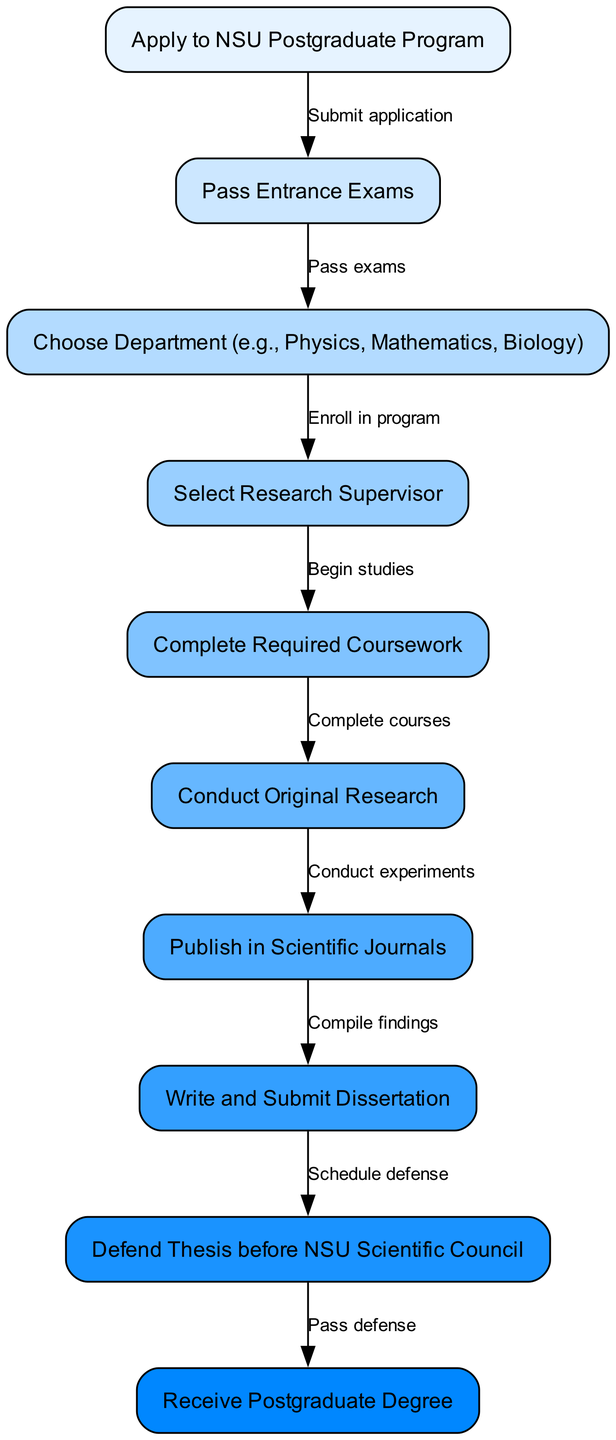What is the first step in obtaining a postgraduate degree at NSU? The diagram shows that the first step is to apply to the NSU Postgraduate Program, indicated by the node labeled "Apply to NSU Postgraduate Program."
Answer: Apply to NSU Postgraduate Program How many nodes are there in the diagram? By counting the nodes listed in the data, there are a total of 10 nodes.
Answer: 10 What is required to advance from "Entrance Exams" to "Choose Department"? The edge connecting these two nodes states that one must pass the exams to proceed, as specified in the text on that edge.
Answer: Pass exams What is the last step before receiving the postgraduate degree? The diagram shows that one must pass the defense first, which is the final step indicated before receiving the degree.
Answer: Pass defense Which step follows "Conduct Original Research"? According to the flow of the diagram, after conducting research, the next step is to publish findings in scientific journals. This is demonstrated by the edge linking these two nodes.
Answer: Publish in Scientific Journals What happens directly after completing required coursework? Upon completing required coursework, the next step is to conduct original research, as illustrated by the connection from "Complete Required Coursework" to "Conduct Original Research."
Answer: Conduct Original Research How many edges are listed in the diagram? By examining the edges provided in the data, there are a total of 9 edges that indicate the connections and transitions between nodes.
Answer: 9 What must be done before writing and submitting the dissertation? The diagram indicates that one must first publish their findings in scientific journals after conducting original research, which comes before writing the dissertation.
Answer: Publish in Scientific Journals Which department choices are specified in the "Choose Department" step? The diagram allows for specific choices such as Physics, Mathematics, and Biology as per the text in the "Choose Department" node.
Answer: Physics, Mathematics, Biology 